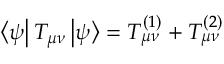<formula> <loc_0><loc_0><loc_500><loc_500>\left < \psi \right | T _ { \mu \nu } \left | \psi \right > = T _ { \mu \nu } ^ { ( 1 ) } + T _ { \mu \nu } ^ { ( 2 ) }</formula> 